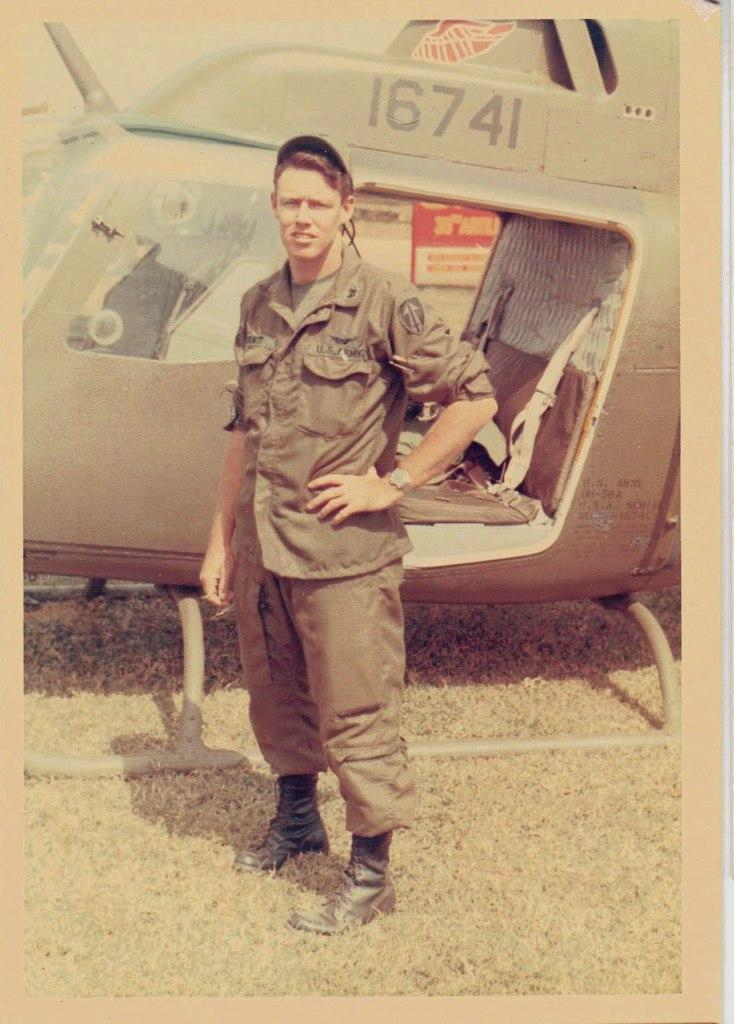What is the main subject of the image? There is a person standing in the image. Can you describe the person's attire? The person is wearing clothes. What else can be seen in the image besides the person? There is a helicopter in the middle of the image. What type of fan can be seen in the image? There is no fan present in the image. Is there any sleet visible in the image? There is no mention of sleet in the provided facts, and it is not visible in the image. 